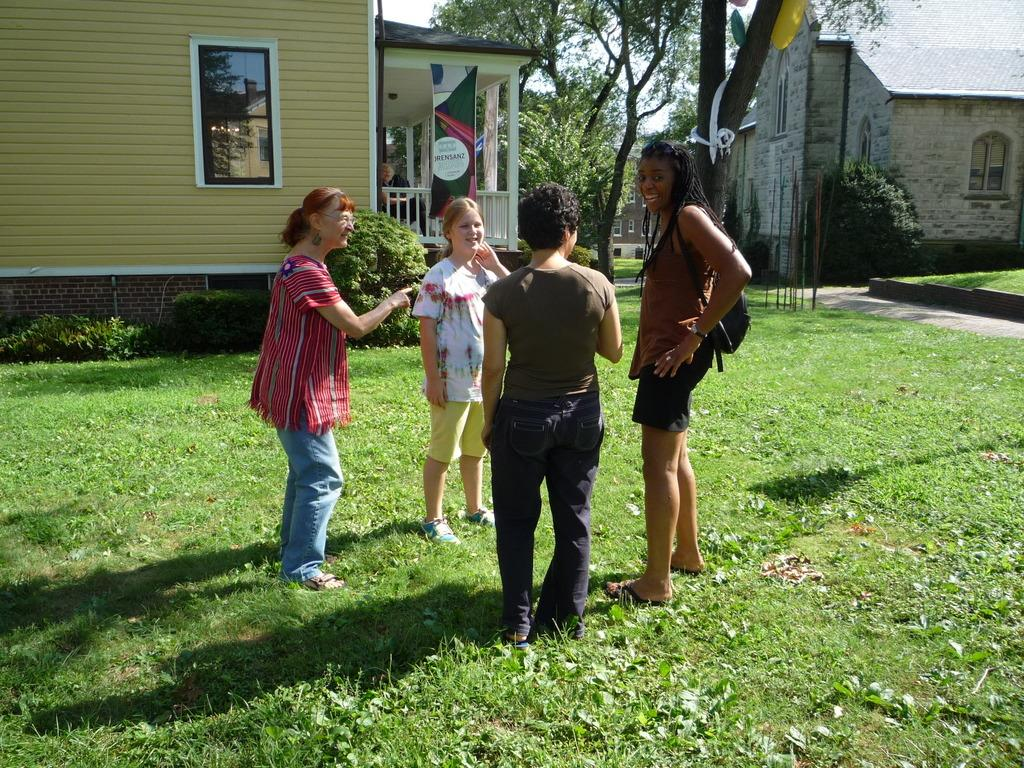How many women are present in the image? There are four women in the image. What is the surface the women are standing on? The women are standing on the ground. What type of vegetation is present on the ground? There is grass on the ground. What can be seen in the background of the image? There are houses and trees in the background of the image. What type of degree is being exchanged between the women in the image? There is no indication in the image that the women are exchanging any degrees. 